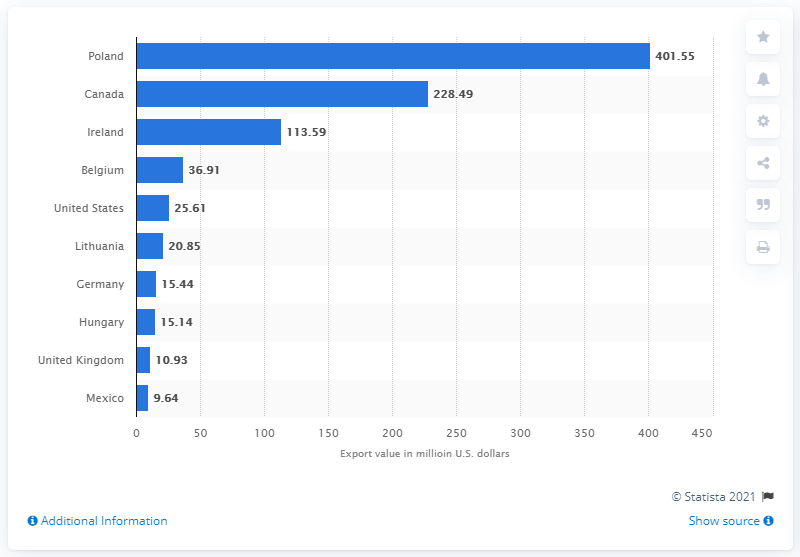Identify some key points in this picture. In 2019, Poland's export value was 401.55 billion dollars. Poland was the leading global exporter of mushrooms in 2019, according to the latest statistics. 